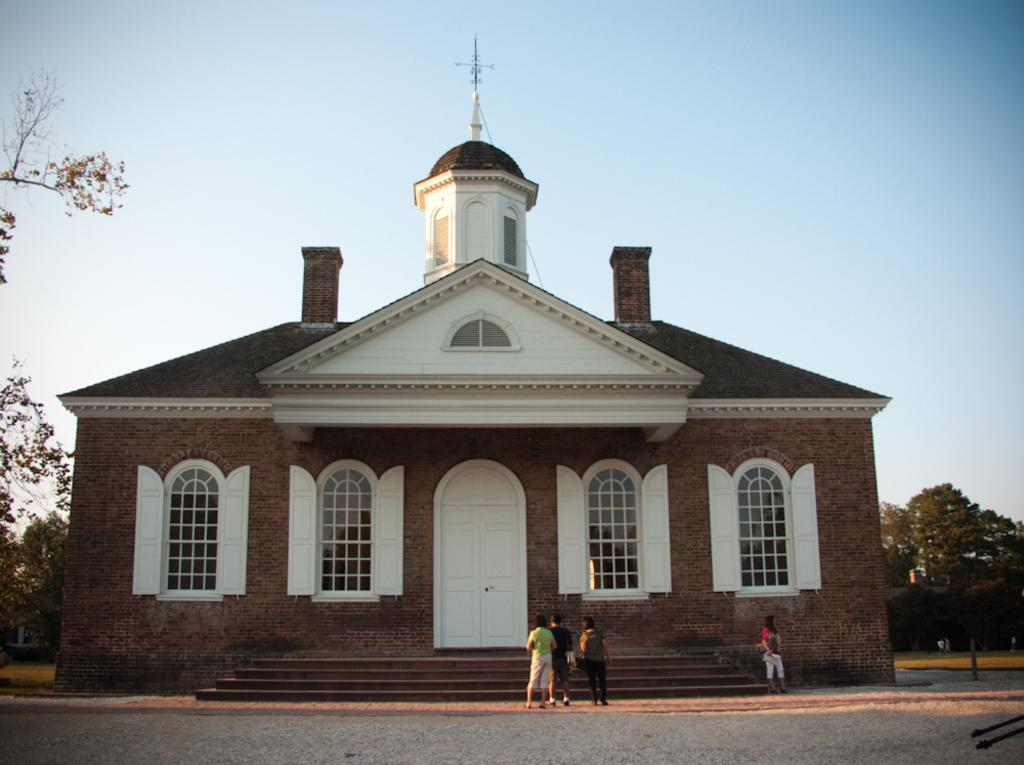What can be seen in the foreground of the image? There are people standing in front of the house. What features can be observed on the house? The house has windows. What type of vegetation is visible in the background? There are many trees in the background. What is visible in the sky in the image? The sky is visible in the background. What type of design can be seen on the vest worn by the people in the image? There is no vest visible in the image, and therefore no design can be observed. What is the canvas used for in the image? There is no canvas present in the image. 